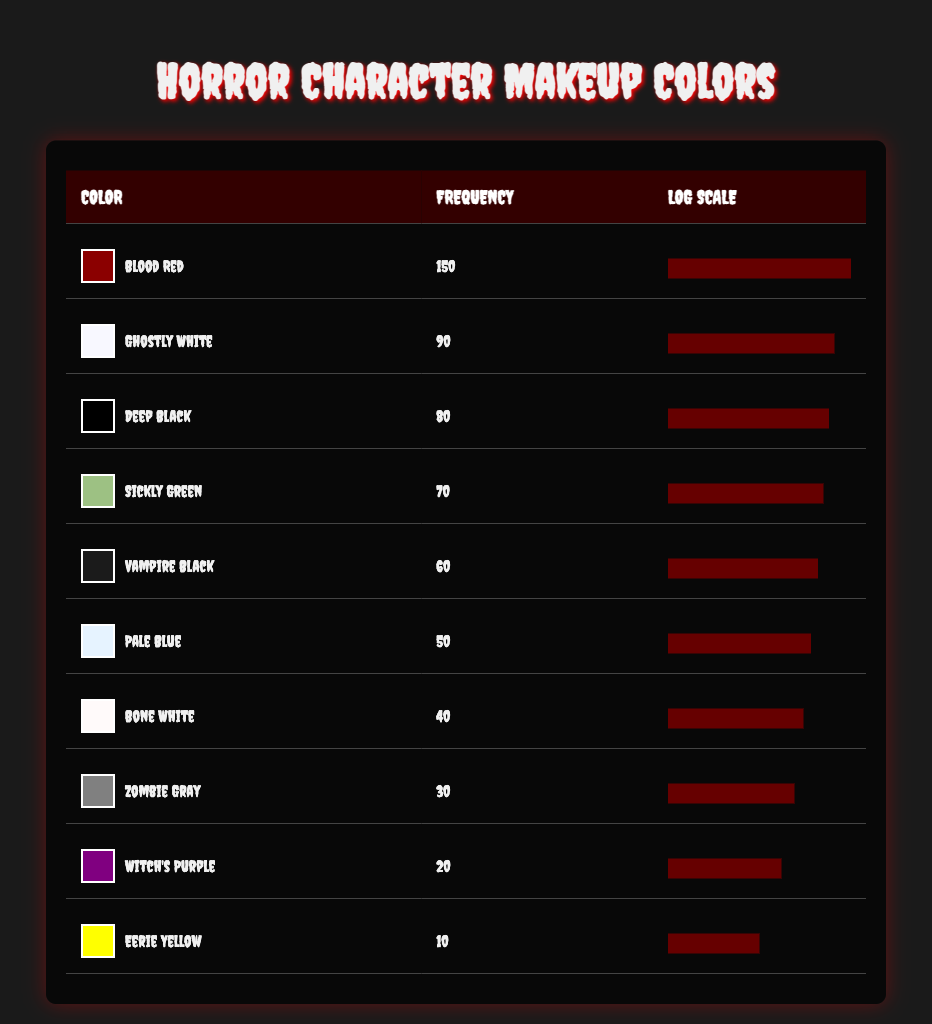What is the color with the highest frequency used in horror character makeup? By examining the frequency values in the table, we can see that "Blood Red" has the highest frequency at 150, making it the most used color for horror character makeup.
Answer: Blood Red How many colors have a frequency of 80 or more? We can look at the frequency column and count the colors that meet or exceed 80. The qualifying colors are "Blood Red," "Ghostly White," "Deep Black," and "Sickly Green," which makes a total of 4 colors.
Answer: 4 What is the frequency of "Witch's Purple"? Directly referring to the table, the frequency for "Witch's Purple" is listed as 20.
Answer: 20 Is "Zombie Gray" more frequently used than "Pale Blue"? We can compare the frequencies of "Zombie Gray," which has a frequency of 30, and "Pale Blue," which has a frequency of 50. Since 30 is less than 50, the statement is false.
Answer: No What is the average frequency of the colors listed in the table? To find the average, we sum all the frequencies: 150 + 90 + 80 + 70 + 60 + 50 + 40 + 30 + 20 + 10 = 650. There are 10 colors in total, so the average frequency is 650 divided by 10, which equals 65.
Answer: 65 How does the frequency of "Eerie Yellow" compare with the frequency of "Bone White"? The frequency for "Eerie Yellow" is 10, while "Bone White" has a frequency of 40. By comparing these values, we find that "Eerie Yellow" is significantly less frequent than "Bone White."
Answer: Eerie Yellow is less frequent If we were to arrange the colors from most to least frequency, what would be the third color? By ordering the frequencies in descending order, we get: 1. Blood Red, 2. Ghostly White, 3. Deep Black. This makes "Deep Black" the third color in terms of frequency.
Answer: Deep Black What is the total frequency of colors that have a frequency lower than 40? We need to identify the colors with a frequency lower than 40, which are "Zombie Gray" (30), "Witch's Purple" (20), and "Eerie Yellow" (10). Adding these together gives us 30 + 20 + 10 = 60.
Answer: 60 